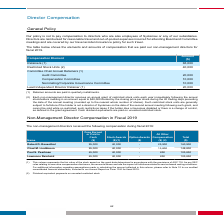From Systemax's financial document, What is the total compensation received by Robert D. Rosenthal and Chad M. Lindbloom respectively during fiscal 2019? The document shows two values: 160,900 and 148,800. From the document: "Chad M. Lindbloom 95,000 40,000 - 13,800 148,800 Robert D. Rosenthal 95,000 40,000 - 25,900 160,900..." Also, What is the total compensation received by Paul S. Pearlman and Lawrence Reinhold respectively during fiscal 2019? The document shows two values: 105,850 and 105,850. From the document: "Paul S. Pearlman 65,000 40,000 - 850 105,850..." Also, What does stock awards refer to? Represents the fair value of the stock award on the grant date determined in accordance with the provisions of ASC 718.. The document states: "(1) This column represents the fair value of the stock award on the grant date determined in accordance with the provisions of ASC 718. As per SEC..." Also, can you calculate: What is the total compensation received by Robert D. Rosenthal and Chad M. Lindbloom during fiscal 2019? Based on the calculation: 160,900 + 148,800 , the result is 309700. This is based on the information: "Chad M. Lindbloom 95,000 40,000 - 13,800 148,800 Robert D. Rosenthal 95,000 40,000 - 25,900 160,900..." The key data points involved are: 148,800, 160,900. Also, can you calculate: What is the total compensation received by Paul S. Pearlman and Lawrence Reinhold during fiscal 2019? Based on the calculation: 105,850 + 105,850 , the result is 211700. This is based on the information: "Paul S. Pearlman 65,000 40,000 - 850 105,850..." Also, can you calculate: What is the percentage of Pearlman's fees earned in cash as a percentage of his total compensation during fiscal 2019? Based on the calculation: 65,000/105,850 , the result is 61.41 (percentage). This is based on the information: "Paul S. Pearlman 65,000 40,000 - 850 105,850 Paul S. Pearlman 65,000 40,000 - 850 105,850..." The key data points involved are: 105,850, 65,000. 